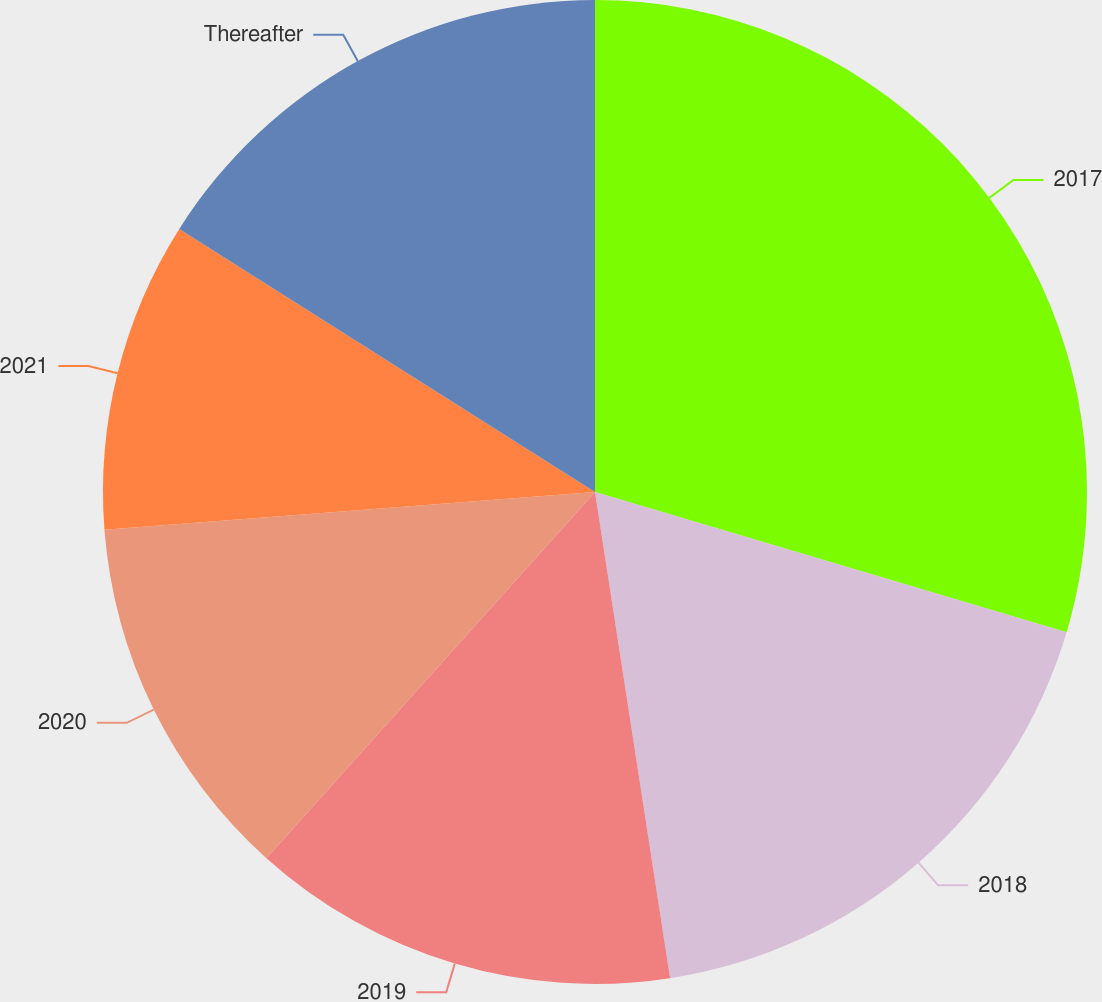Convert chart. <chart><loc_0><loc_0><loc_500><loc_500><pie_chart><fcel>2017<fcel>2018<fcel>2019<fcel>2020<fcel>2021<fcel>Thereafter<nl><fcel>29.6%<fcel>17.96%<fcel>14.08%<fcel>12.14%<fcel>10.2%<fcel>16.02%<nl></chart> 